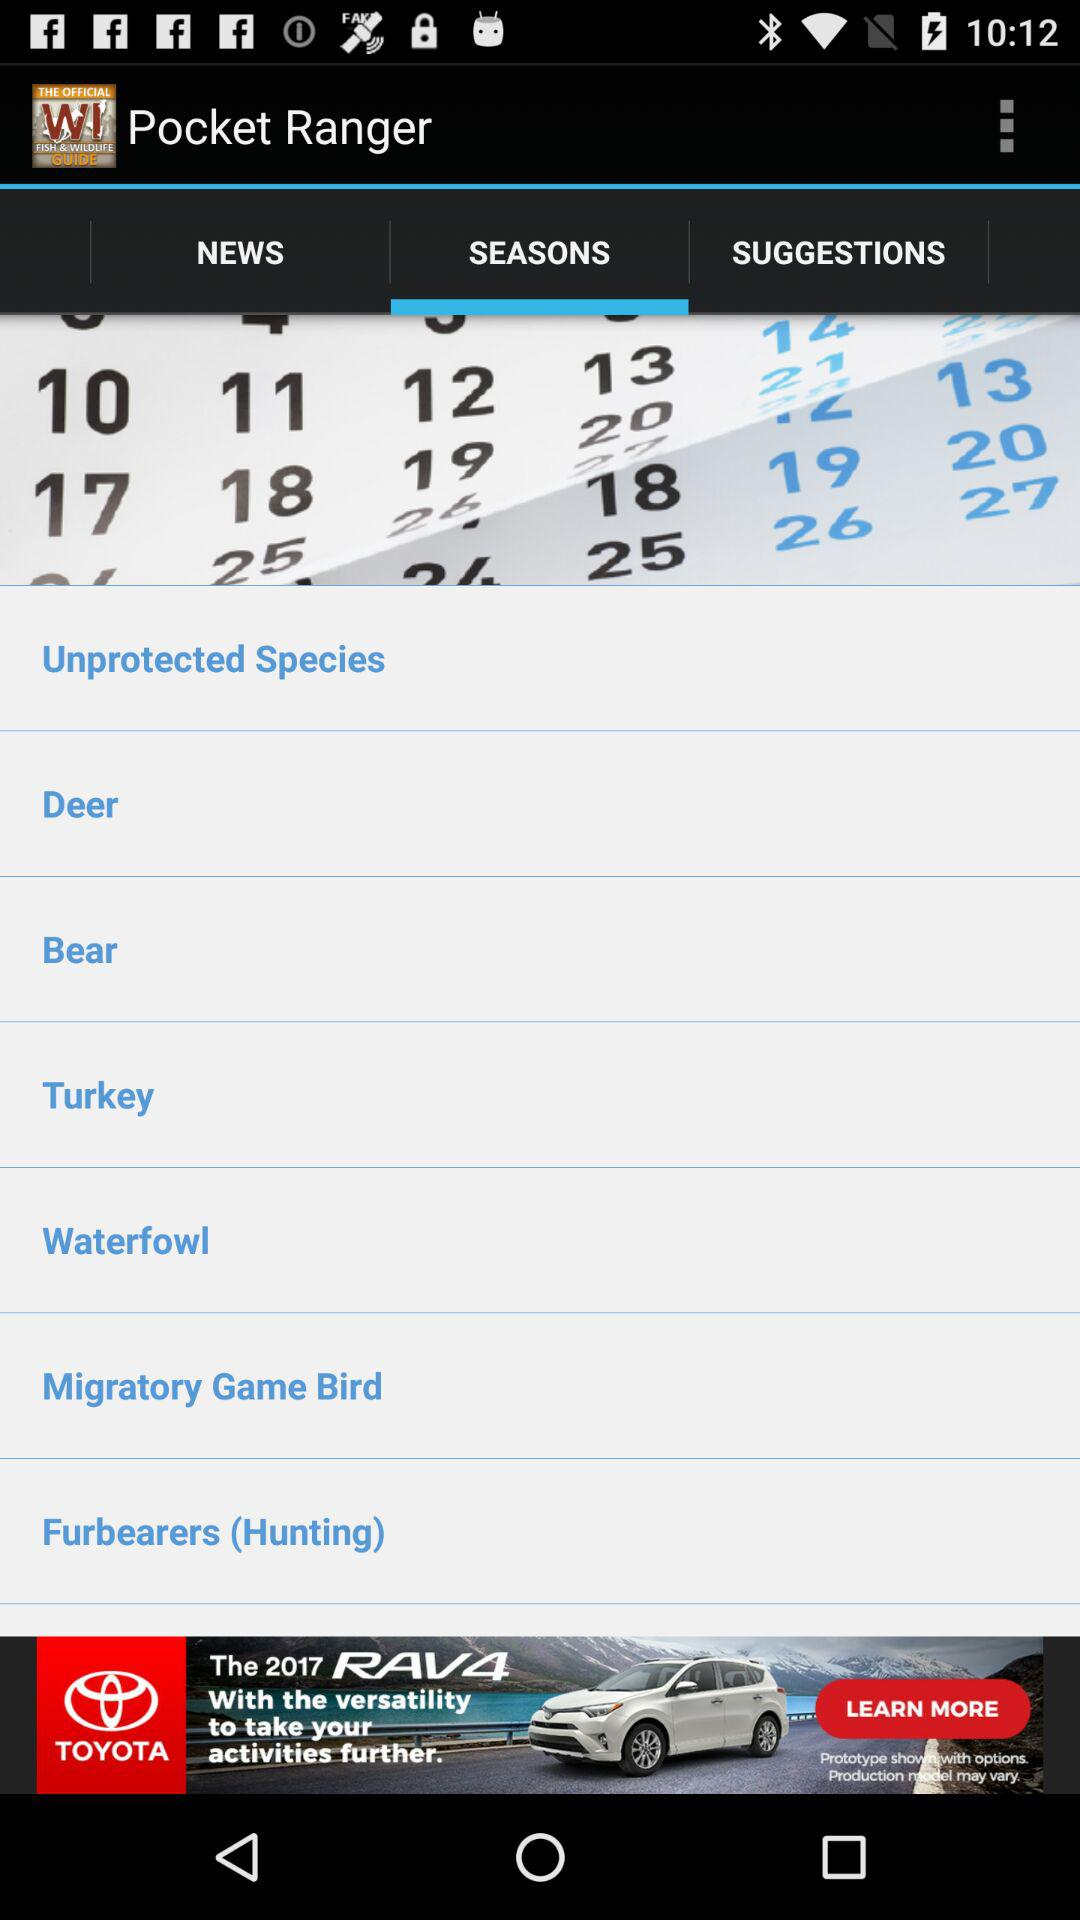Which tab of "Pocket Ranger" am I on? You are on the "Seasons" tab. 